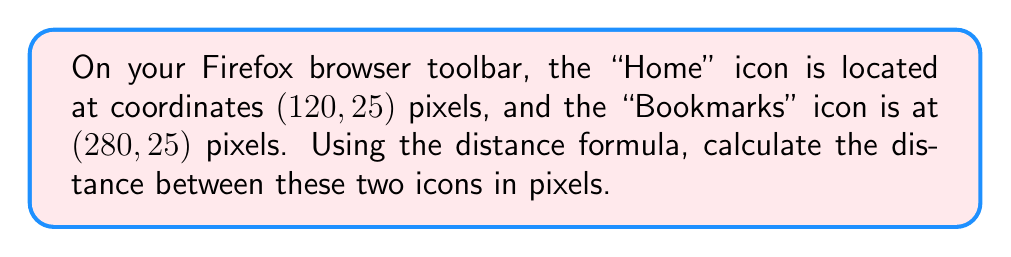Help me with this question. To solve this problem, we'll use the distance formula, which is derived from the Pythagorean theorem. The distance formula for two points $(x_1, y_1)$ and $(x_2, y_2)$ is:

$$ d = \sqrt{(x_2 - x_1)^2 + (y_2 - y_1)^2} $$

Let's plug in our values:
- Home icon: $(x_1, y_1) = (120, 25)$
- Bookmarks icon: $(x_2, y_2) = (280, 25)$

Now, let's calculate step by step:

1) First, we'll subtract the x-coordinates and y-coordinates:
   $x_2 - x_1 = 280 - 120 = 160$
   $y_2 - y_1 = 25 - 25 = 0$

2) Now, we'll square these differences:
   $(x_2 - x_1)^2 = 160^2 = 25,600$
   $(y_2 - y_1)^2 = 0^2 = 0$

3) Add these squared differences:
   $25,600 + 0 = 25,600$

4) Take the square root of this sum:
   $\sqrt{25,600} = 160$

Therefore, the distance between the two icons is 160 pixels.
Answer: $160$ pixels 